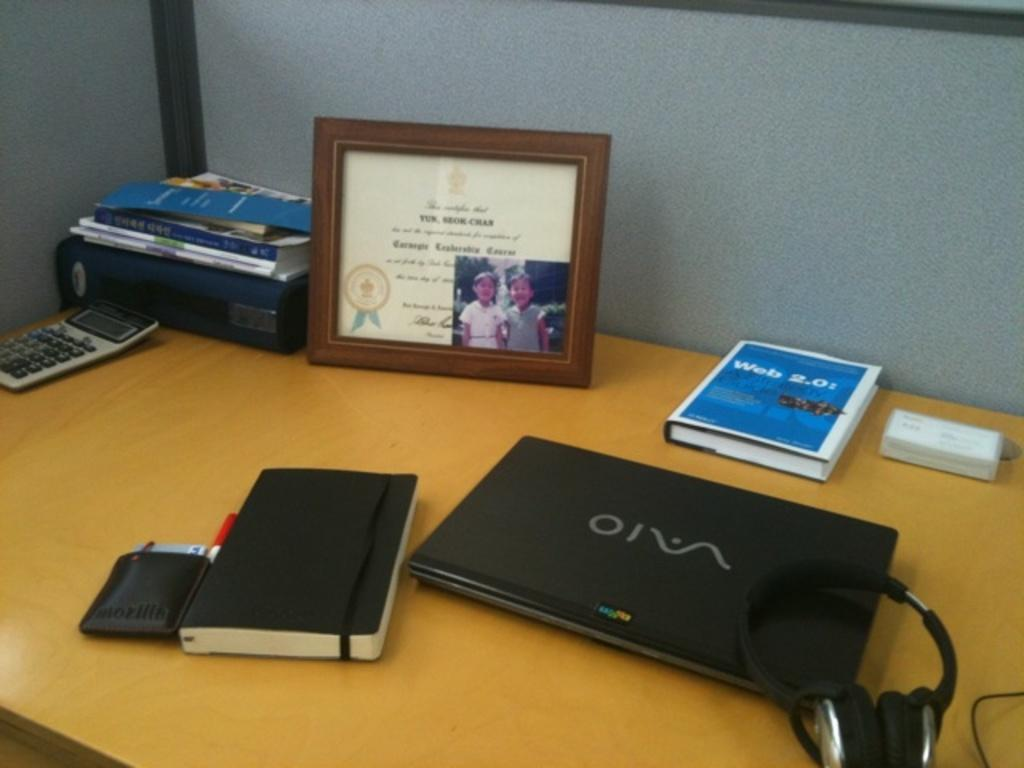Provide a one-sentence caption for the provided image. A laptop is displayed on a desk next to the book Web 2.0. 